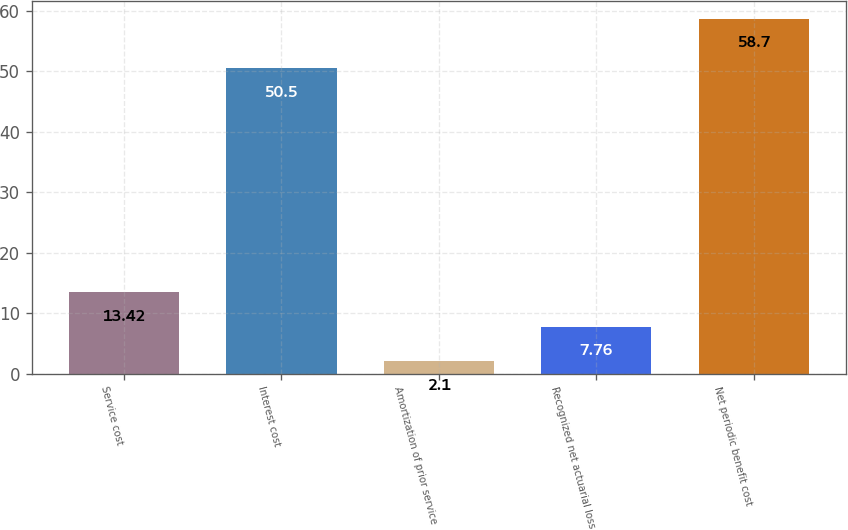Convert chart. <chart><loc_0><loc_0><loc_500><loc_500><bar_chart><fcel>Service cost<fcel>Interest cost<fcel>Amortization of prior service<fcel>Recognized net actuarial loss<fcel>Net periodic benefit cost<nl><fcel>13.42<fcel>50.5<fcel>2.1<fcel>7.76<fcel>58.7<nl></chart> 